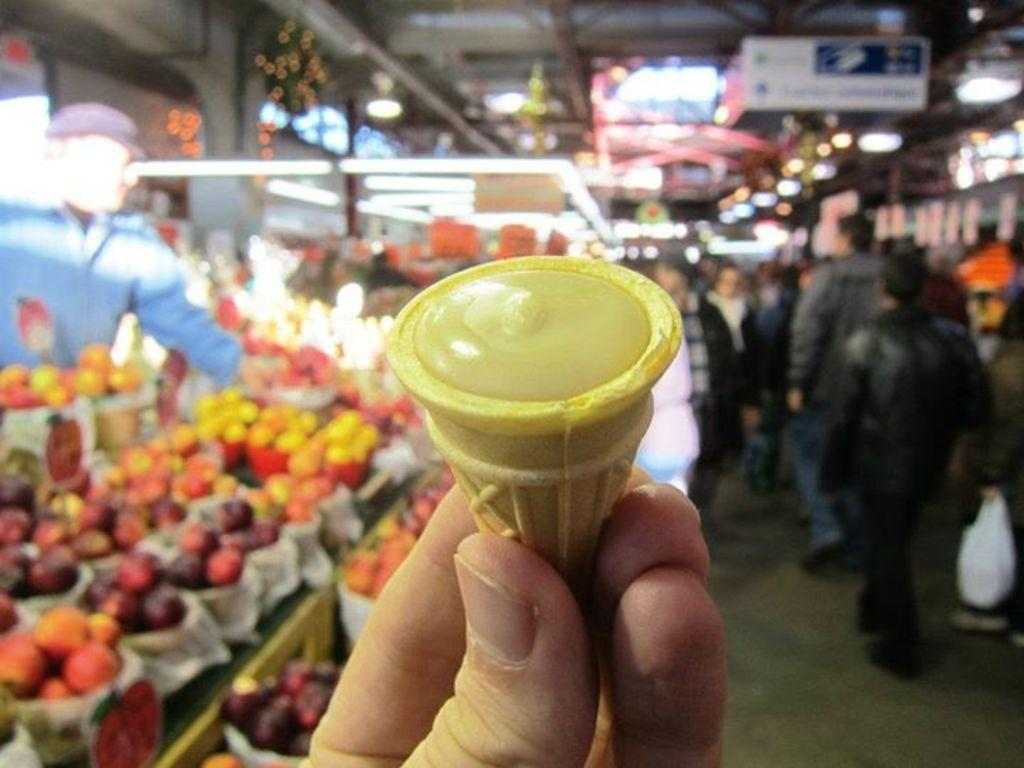What is the person in the image holding? The person is holding a food item in the image. What type of food is the person holding? The specific type of food is not mentioned, but it is a food item. What else can be seen in the image besides the person holding the food item? There are fruits, people walking, and boards visible in the image. Can you describe the appearance of the blurred things in the image? The blurred things in the image are not clearly visible, so it is difficult to describe their appearance. What scientific experiment is being conducted with the bricks in the image? There is no scientific experiment or bricks present in the image. Can you describe the facial expressions of the people in the image? The facial expressions of the people in the image are not visible or discernible due to the blurred appearance of the individuals. 